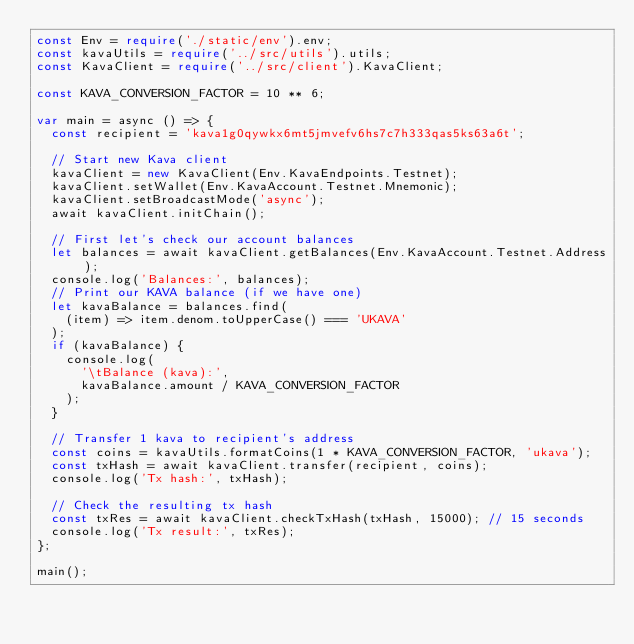<code> <loc_0><loc_0><loc_500><loc_500><_TypeScript_>const Env = require('./static/env').env;
const kavaUtils = require('../src/utils').utils;
const KavaClient = require('../src/client').KavaClient;

const KAVA_CONVERSION_FACTOR = 10 ** 6;

var main = async () => {
  const recipient = 'kava1g0qywkx6mt5jmvefv6hs7c7h333qas5ks63a6t';

  // Start new Kava client
  kavaClient = new KavaClient(Env.KavaEndpoints.Testnet);
  kavaClient.setWallet(Env.KavaAccount.Testnet.Mnemonic);
  kavaClient.setBroadcastMode('async');
  await kavaClient.initChain();

  // First let's check our account balances
  let balances = await kavaClient.getBalances(Env.KavaAccount.Testnet.Address);
  console.log('Balances:', balances);
  // Print our KAVA balance (if we have one)
  let kavaBalance = balances.find(
    (item) => item.denom.toUpperCase() === 'UKAVA'
  );
  if (kavaBalance) {
    console.log(
      '\tBalance (kava):',
      kavaBalance.amount / KAVA_CONVERSION_FACTOR
    );
  }

  // Transfer 1 kava to recipient's address
  const coins = kavaUtils.formatCoins(1 * KAVA_CONVERSION_FACTOR, 'ukava');
  const txHash = await kavaClient.transfer(recipient, coins);
  console.log('Tx hash:', txHash);

  // Check the resulting tx hash
  const txRes = await kavaClient.checkTxHash(txHash, 15000); // 15 seconds
  console.log('Tx result:', txRes);
};

main();
</code> 